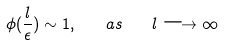Convert formula to latex. <formula><loc_0><loc_0><loc_500><loc_500>\phi ( \frac { l } { \epsilon } ) \sim 1 , \quad a s \quad l \longrightarrow \infty</formula> 